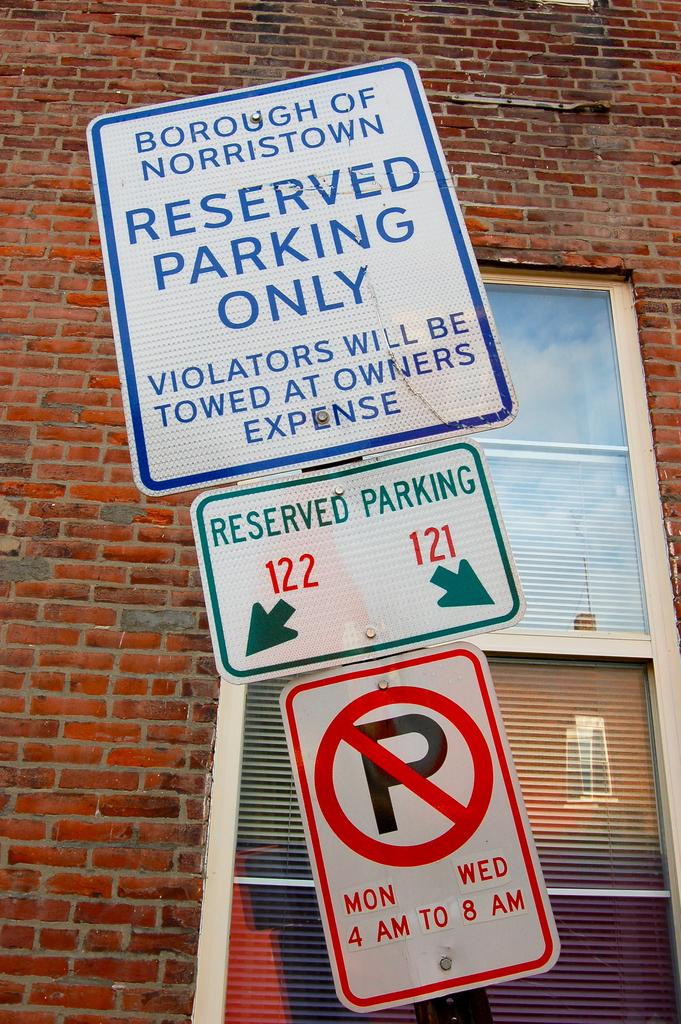<image>
Offer a succinct explanation of the picture presented. Signs for parking in Norristown is shown including the hours for parking. 